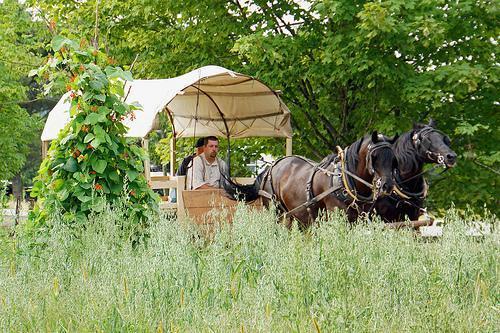How many people are wearing a hat?
Give a very brief answer. 1. 